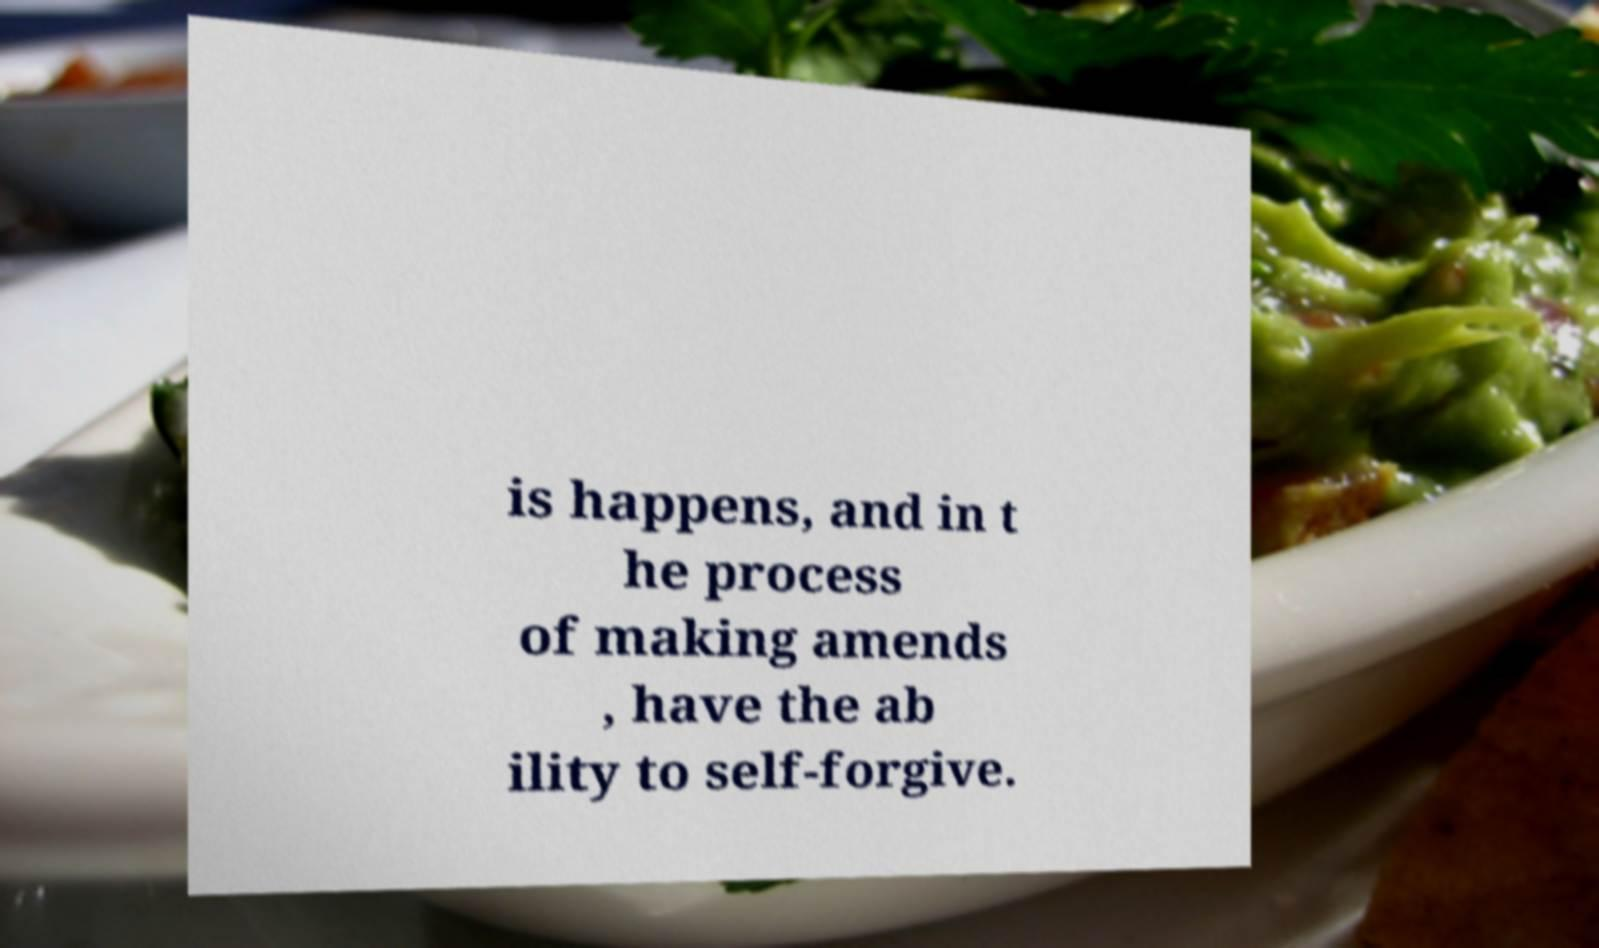Can you read and provide the text displayed in the image?This photo seems to have some interesting text. Can you extract and type it out for me? is happens, and in t he process of making amends , have the ab ility to self-forgive. 